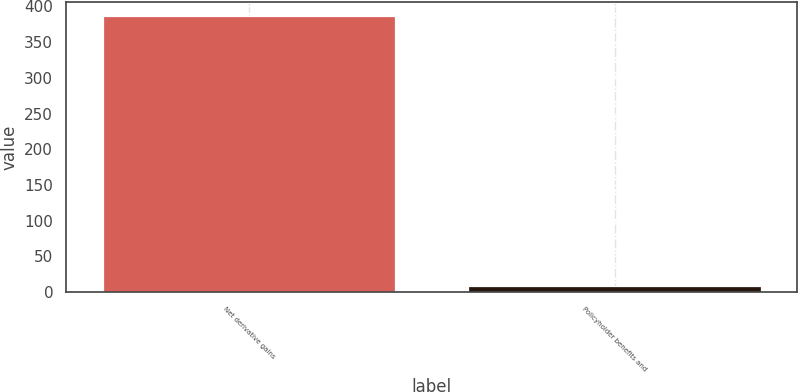Convert chart. <chart><loc_0><loc_0><loc_500><loc_500><bar_chart><fcel>Net derivative gains<fcel>Policyholder benefits and<nl><fcel>387<fcel>8<nl></chart> 